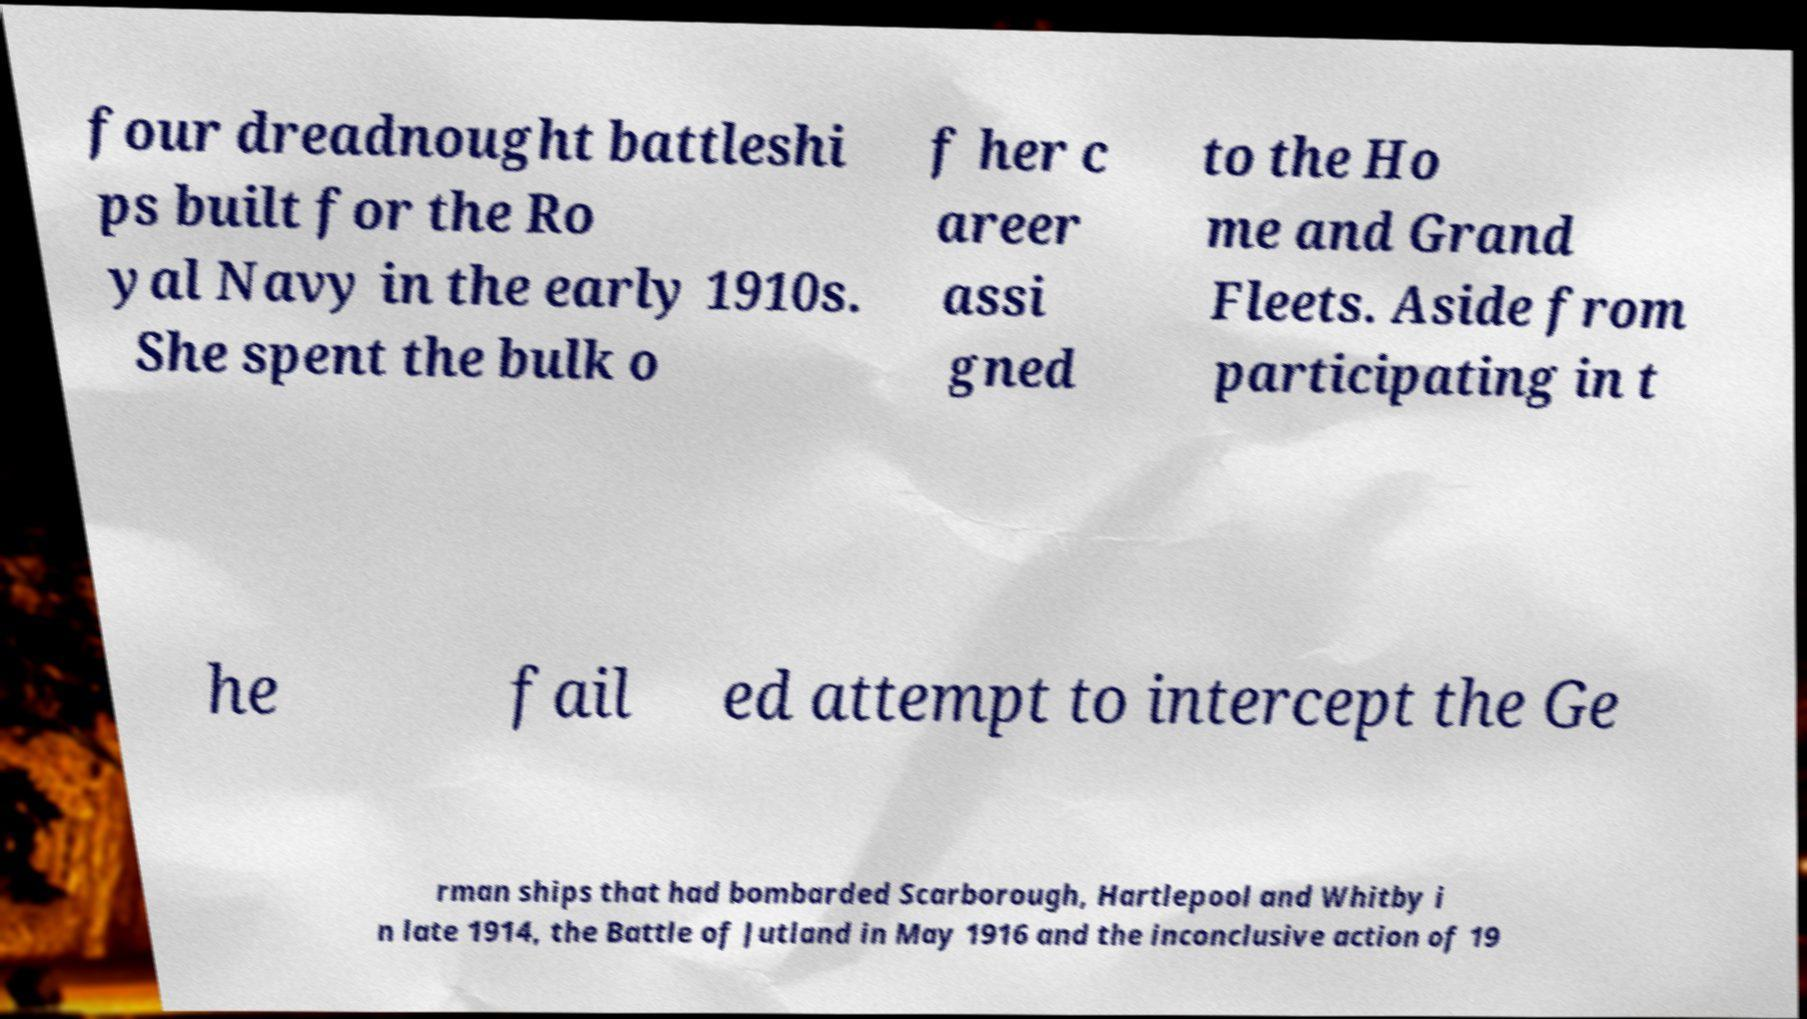Could you assist in decoding the text presented in this image and type it out clearly? four dreadnought battleshi ps built for the Ro yal Navy in the early 1910s. She spent the bulk o f her c areer assi gned to the Ho me and Grand Fleets. Aside from participating in t he fail ed attempt to intercept the Ge rman ships that had bombarded Scarborough, Hartlepool and Whitby i n late 1914, the Battle of Jutland in May 1916 and the inconclusive action of 19 